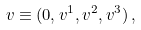Convert formula to latex. <formula><loc_0><loc_0><loc_500><loc_500>v \equiv ( 0 , v ^ { 1 } , v ^ { 2 } , v ^ { 3 } ) \, ,</formula> 